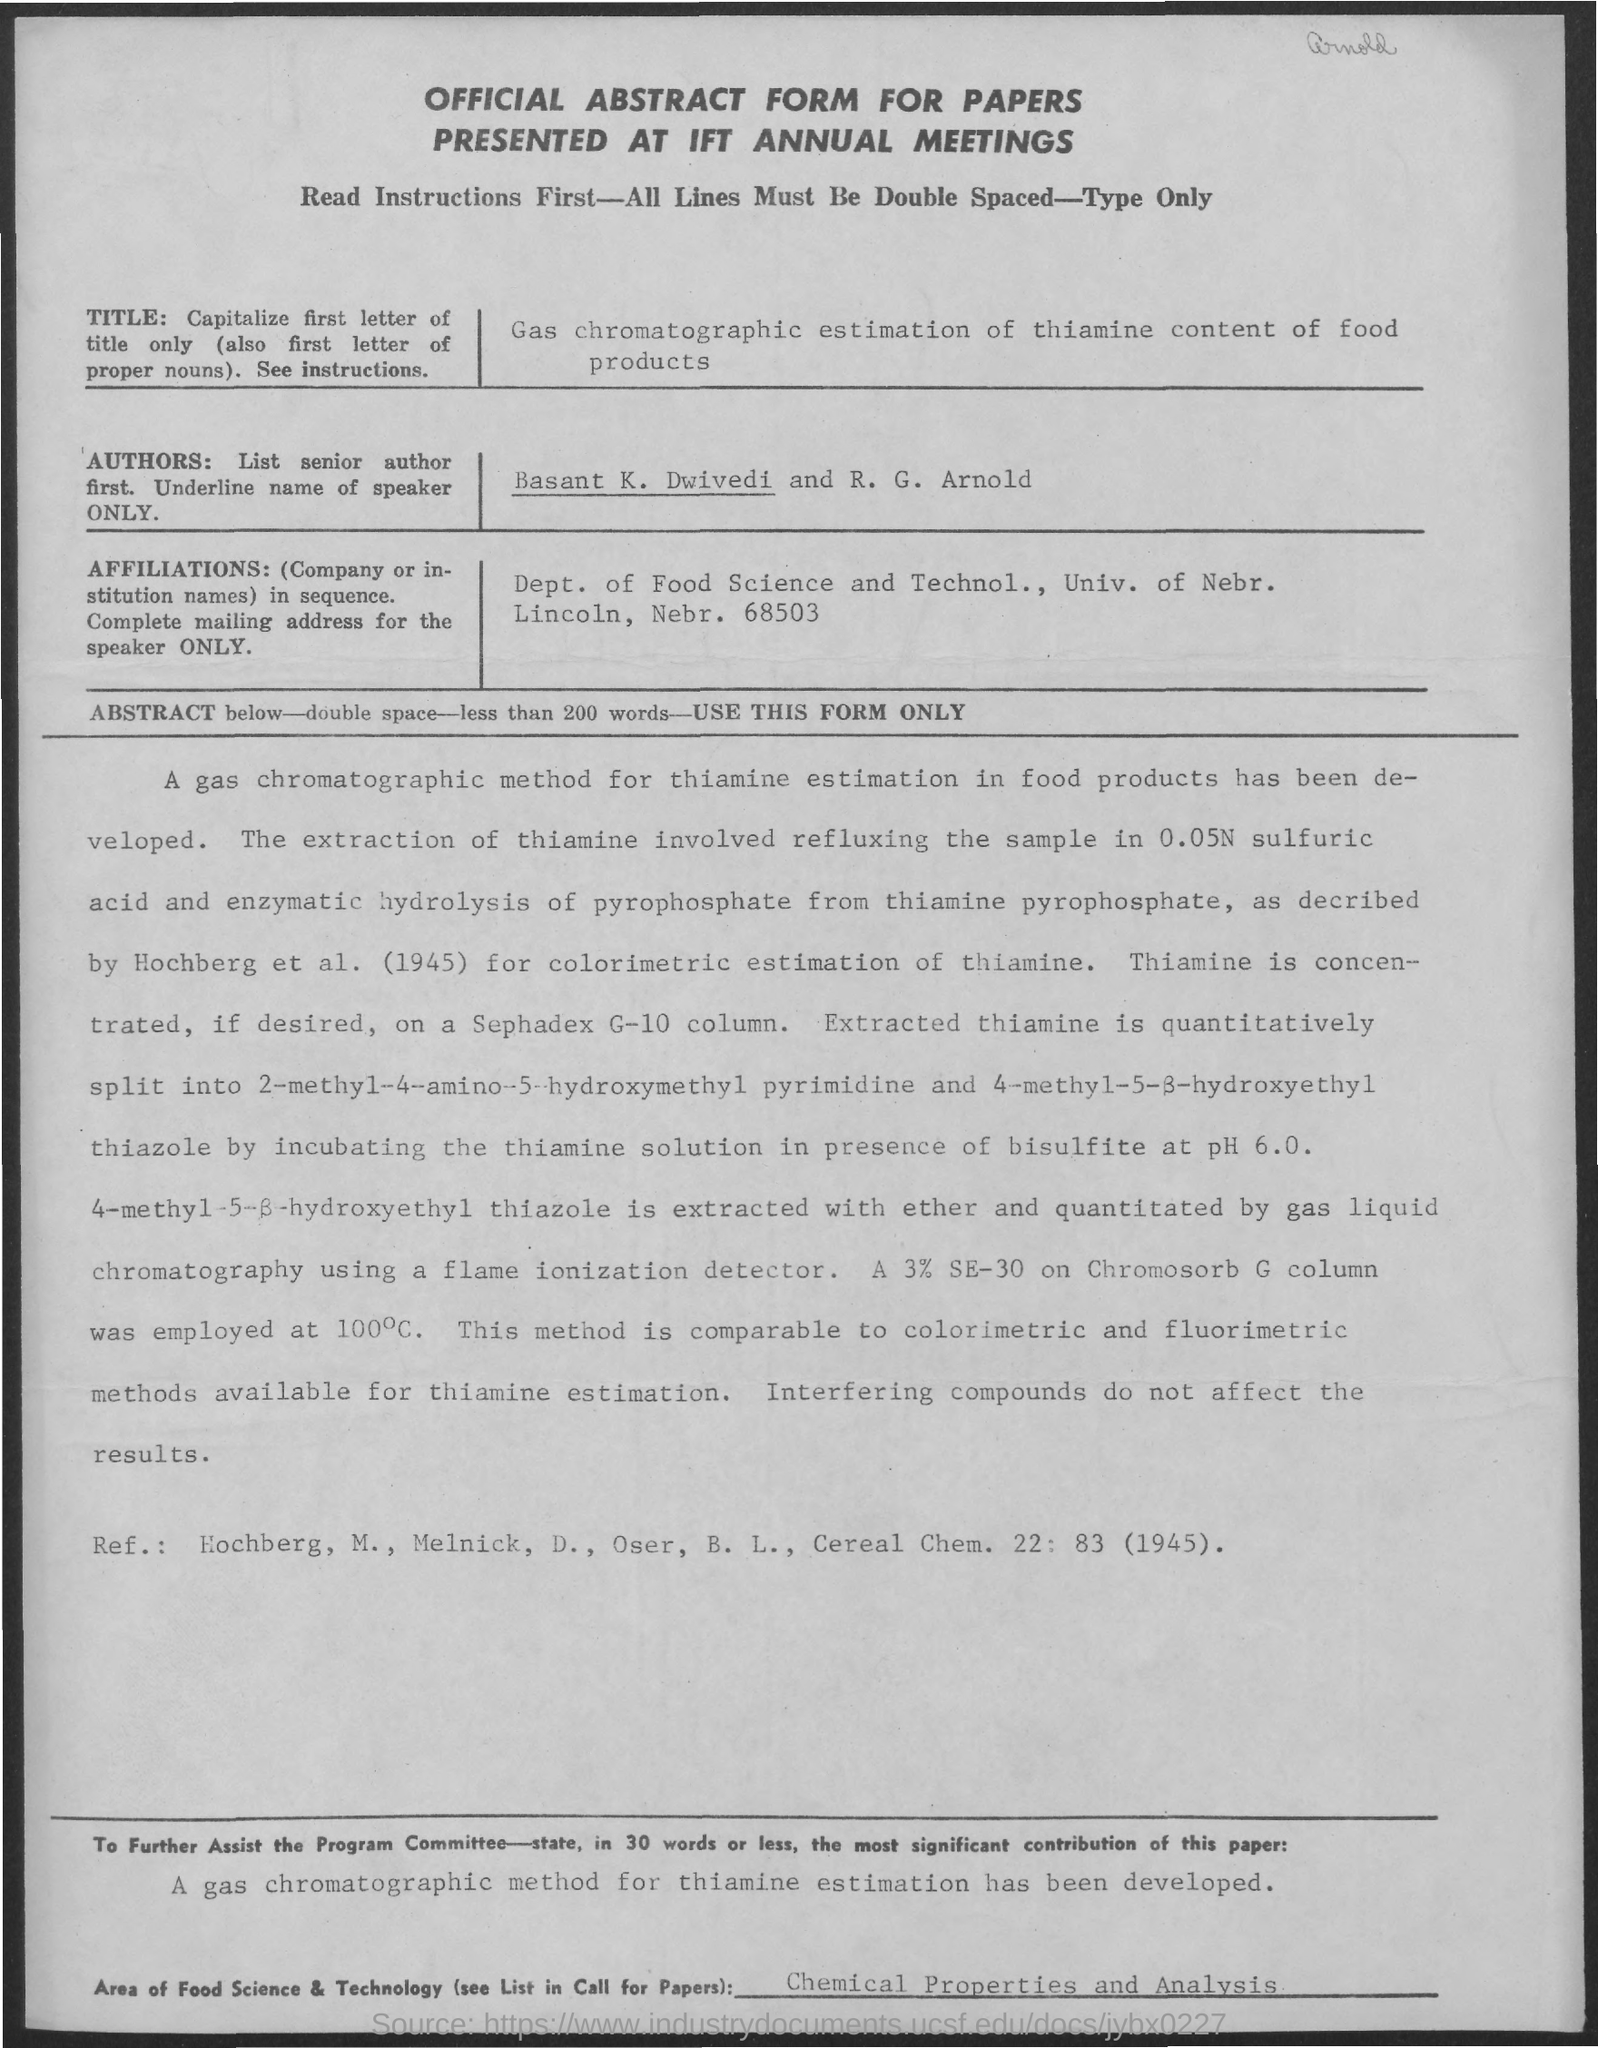Give some essential details in this illustration. The title of the paper is "Gas Chromatographic Estimation of Thiamine Content of Food Products." The document titled "Official Abstract Form for Papers Presented at IFT Annual Meetings" is an official form used for presenting papers at annual meetings of the Institute of Food Technologists. The authors of this article are Basant K. Dwivedi and R. G. Arnold. 